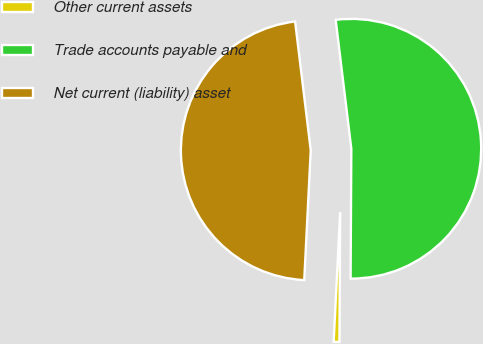Convert chart. <chart><loc_0><loc_0><loc_500><loc_500><pie_chart><fcel>Other current assets<fcel>Trade accounts payable and<fcel>Net current (liability) asset<nl><fcel>0.71%<fcel>52.01%<fcel>47.28%<nl></chart> 